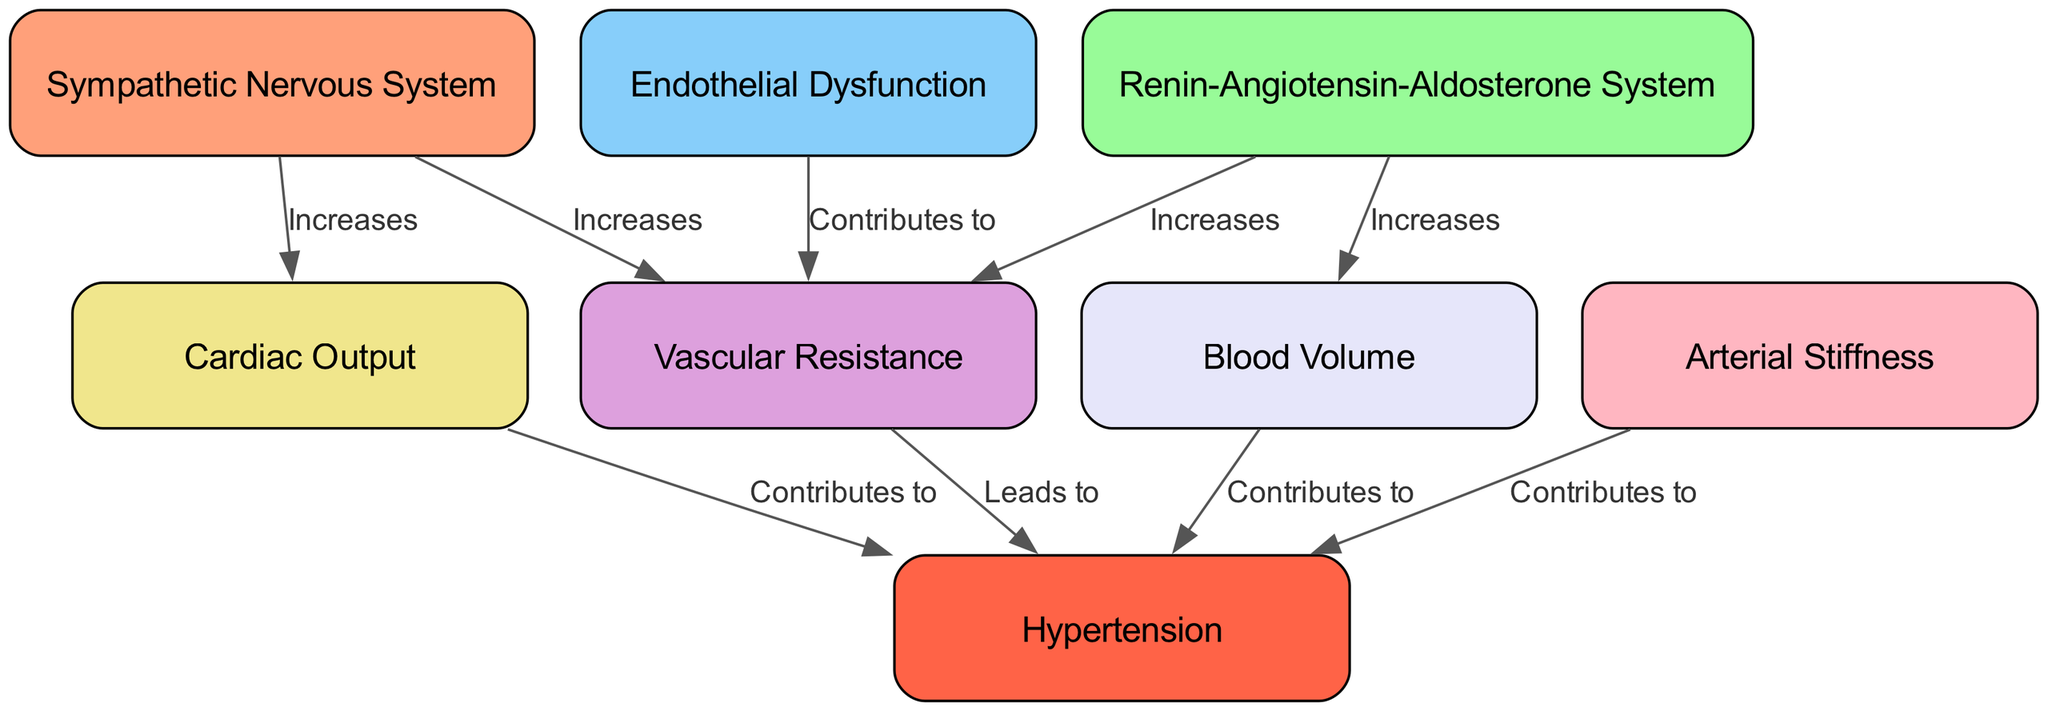What are the contributing factors to hypertension depicted in this diagram? The diagram shows several nodes that contribute to hypertension: Vascular Resistance, Cardiac Output, Blood Volume, and Arterial Stiffness. Each of these factors has an edge pointing to the Hypertension node, indicating their contribution to the condition.
Answer: Vascular Resistance, Cardiac Output, Blood Volume, Arterial Stiffness Which system is associated with increasing both vascular resistance and cardiac output? The diagram shows that the Sympathetic Nervous System has edges leading to both Vascular Resistance and Cardiac Output, indicating that it has a role in increasing both of these factors.
Answer: Sympathetic Nervous System How many nodes are present in this diagram? The diagram lists a total of eight unique factors or systems related to hypertension, as represented by the nodes, thus summing them gives the total node count.
Answer: Eight What effect does the Renin-Angiotensin-Aldosterone System have on blood volume? According to the diagram, the Renin-Angiotensin-Aldosterone System has a directed edge leading to Blood Volume with the action labeling "Increases," indicating a positive effect on blood volume.
Answer: Increases Describe the flow from Endothelial Dysfunction to Hypertension through Vascular Resistance. The diagram illustrates that Endothelial Dysfunction contributes to an increase in Vascular Resistance. Subsequently, Vascular Resistance leads to Hypertension, forming a flow from one node to the next, resulting in the final state of Hypertension.
Answer: Endothelial Dysfunction → Vascular Resistance → Hypertension 